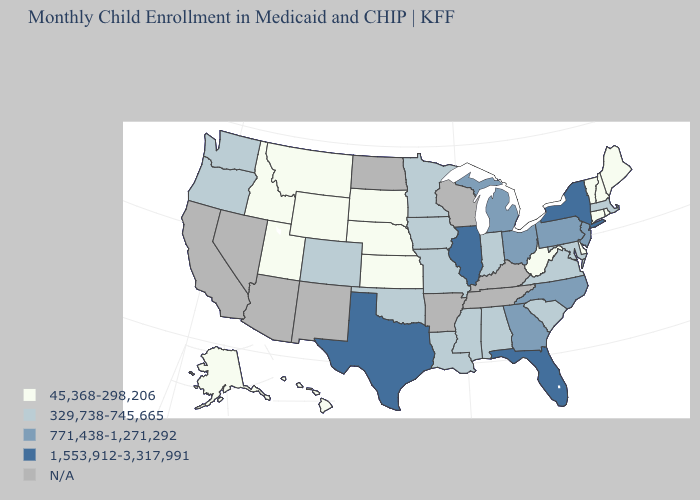Does Wyoming have the lowest value in the West?
Answer briefly. Yes. What is the lowest value in the USA?
Concise answer only. 45,368-298,206. What is the value of Nebraska?
Give a very brief answer. 45,368-298,206. Among the states that border Kansas , which have the lowest value?
Give a very brief answer. Nebraska. What is the value of Virginia?
Keep it brief. 329,738-745,665. What is the lowest value in states that border Washington?
Short answer required. 45,368-298,206. What is the value of South Dakota?
Keep it brief. 45,368-298,206. What is the lowest value in the West?
Be succinct. 45,368-298,206. Among the states that border Pennsylvania , which have the lowest value?
Short answer required. Delaware, West Virginia. What is the value of Michigan?
Keep it brief. 771,438-1,271,292. Which states have the lowest value in the USA?
Short answer required. Alaska, Connecticut, Delaware, Hawaii, Idaho, Kansas, Maine, Montana, Nebraska, New Hampshire, Rhode Island, South Dakota, Utah, Vermont, West Virginia, Wyoming. What is the highest value in states that border Montana?
Answer briefly. 45,368-298,206. Which states hav the highest value in the West?
Short answer required. Colorado, Oregon, Washington. Does Mississippi have the lowest value in the USA?
Short answer required. No. Name the states that have a value in the range N/A?
Write a very short answer. Arizona, Arkansas, California, Kentucky, Nevada, New Mexico, North Dakota, Tennessee, Wisconsin. 